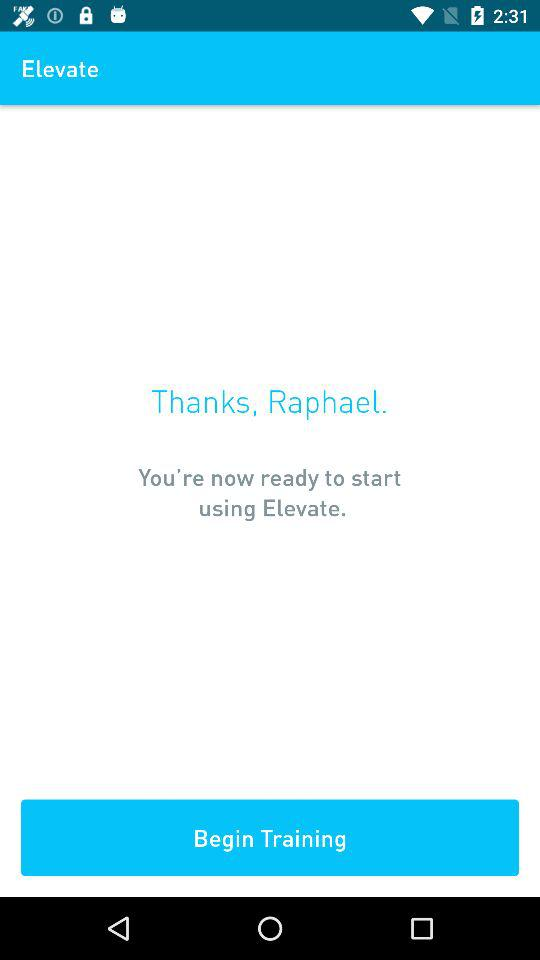How many training levels are there?
When the provided information is insufficient, respond with <no answer>. <no answer> 